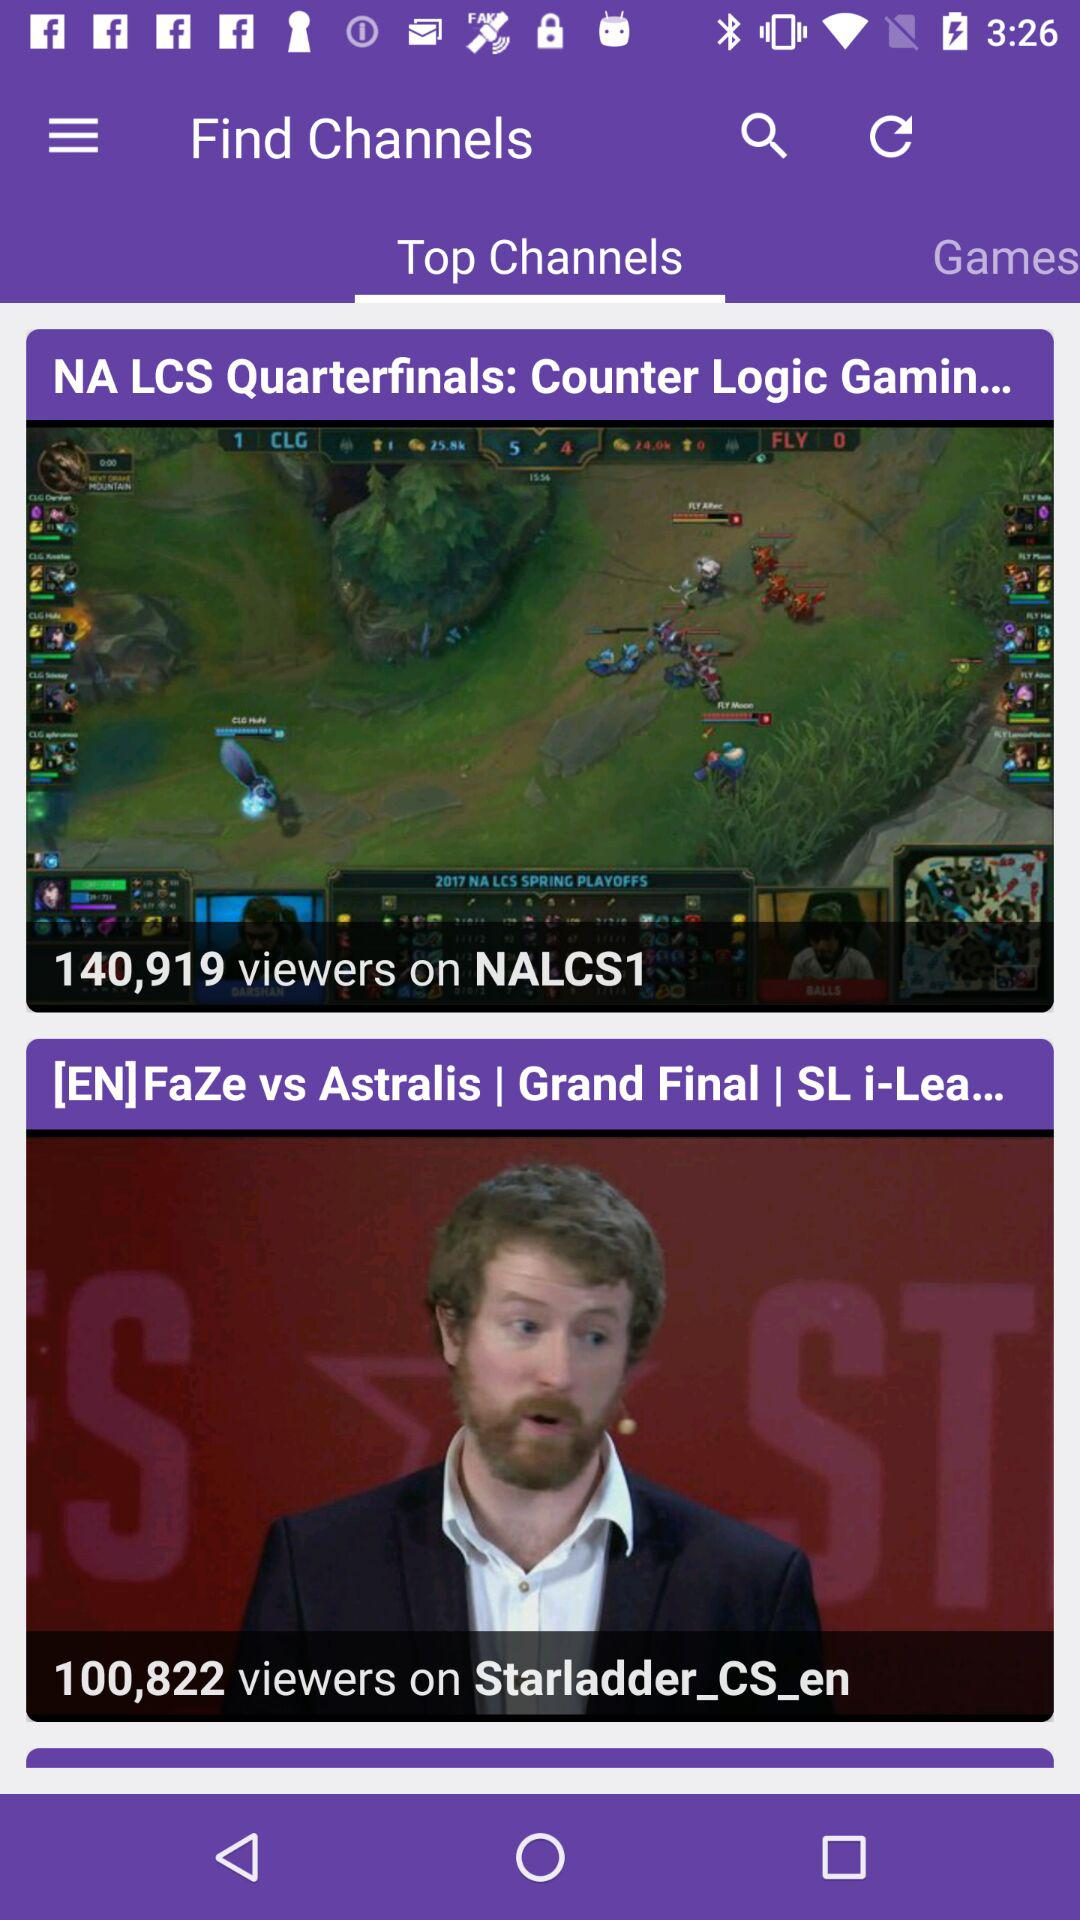How many viewers are there for the "NA LCS Quarterfinals"? There are 140,919 viewers. 